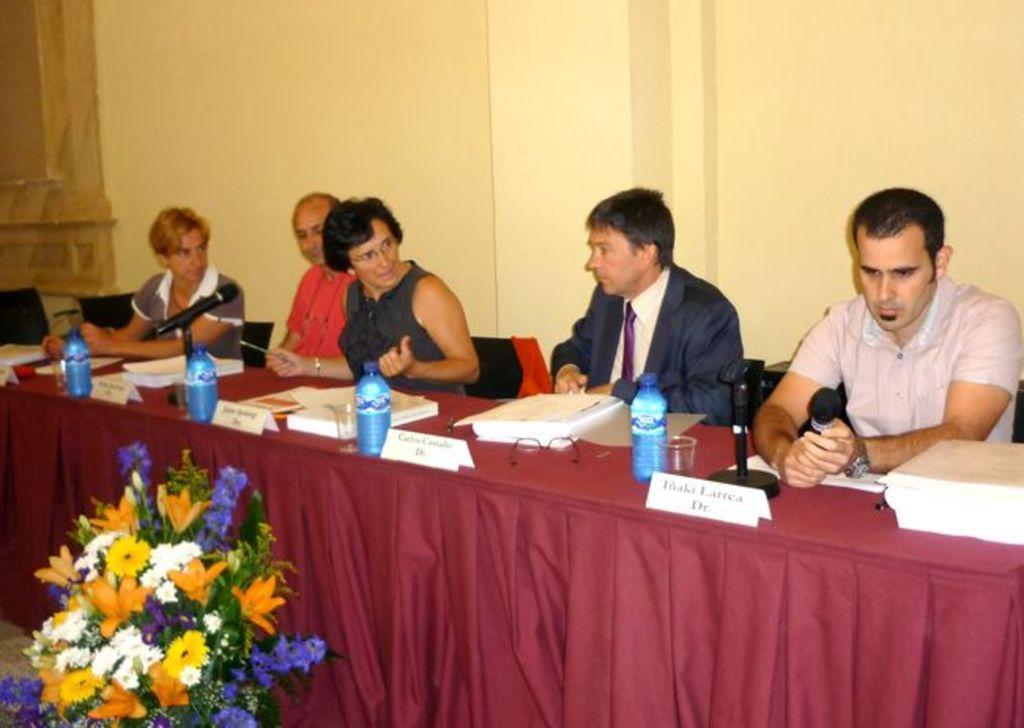Could you give a brief overview of what you see in this image? In this image in the center there are a group of people who are sitting, and in front of them there is a table. And on the table there is a cloth, books, name board, bottles, glasses, mikes and spectacles and some objects. And in the background there is wall and a board, and at the bottom there is a flower bouquet. 